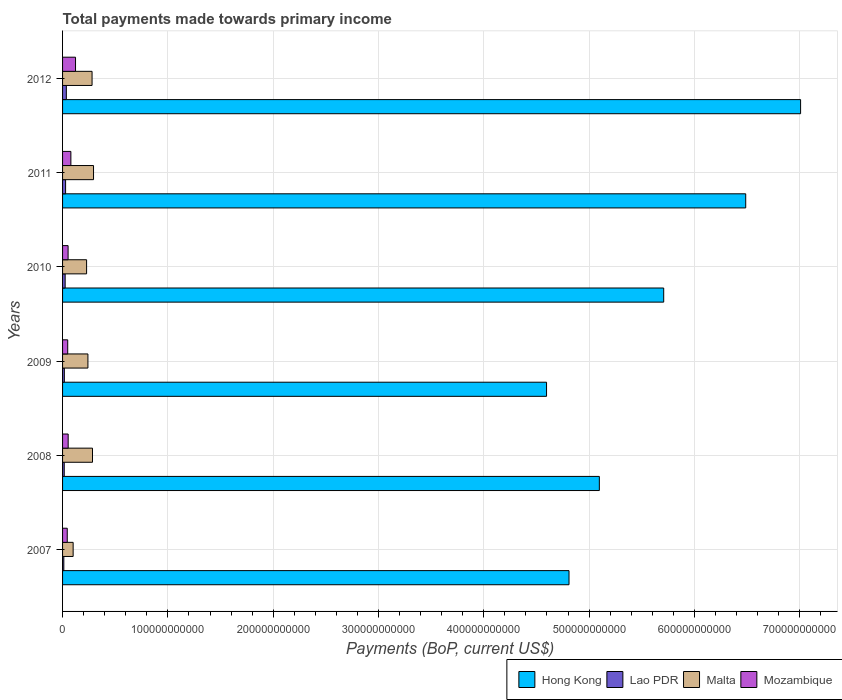How many different coloured bars are there?
Make the answer very short. 4. How many groups of bars are there?
Your response must be concise. 6. Are the number of bars per tick equal to the number of legend labels?
Make the answer very short. Yes. Are the number of bars on each tick of the Y-axis equal?
Keep it short and to the point. Yes. How many bars are there on the 3rd tick from the top?
Your answer should be very brief. 4. In how many cases, is the number of bars for a given year not equal to the number of legend labels?
Provide a succinct answer. 0. What is the total payments made towards primary income in Hong Kong in 2010?
Offer a very short reply. 5.71e+11. Across all years, what is the maximum total payments made towards primary income in Lao PDR?
Your answer should be compact. 3.58e+09. Across all years, what is the minimum total payments made towards primary income in Lao PDR?
Offer a terse response. 1.20e+09. What is the total total payments made towards primary income in Lao PDR in the graph?
Provide a succinct answer. 1.34e+1. What is the difference between the total payments made towards primary income in Lao PDR in 2007 and that in 2011?
Your answer should be compact. -1.68e+09. What is the difference between the total payments made towards primary income in Malta in 2011 and the total payments made towards primary income in Mozambique in 2008?
Your answer should be compact. 2.41e+1. What is the average total payments made towards primary income in Mozambique per year?
Offer a very short reply. 6.69e+09. In the year 2008, what is the difference between the total payments made towards primary income in Lao PDR and total payments made towards primary income in Mozambique?
Give a very brief answer. -3.74e+09. What is the ratio of the total payments made towards primary income in Lao PDR in 2010 to that in 2012?
Make the answer very short. 0.69. Is the total payments made towards primary income in Mozambique in 2010 less than that in 2011?
Keep it short and to the point. Yes. Is the difference between the total payments made towards primary income in Lao PDR in 2009 and 2012 greater than the difference between the total payments made towards primary income in Mozambique in 2009 and 2012?
Ensure brevity in your answer.  Yes. What is the difference between the highest and the second highest total payments made towards primary income in Lao PDR?
Make the answer very short. 7.01e+08. What is the difference between the highest and the lowest total payments made towards primary income in Mozambique?
Your answer should be compact. 7.85e+09. In how many years, is the total payments made towards primary income in Hong Kong greater than the average total payments made towards primary income in Hong Kong taken over all years?
Keep it short and to the point. 3. Is the sum of the total payments made towards primary income in Malta in 2008 and 2012 greater than the maximum total payments made towards primary income in Mozambique across all years?
Provide a succinct answer. Yes. What does the 3rd bar from the top in 2012 represents?
Provide a short and direct response. Lao PDR. What does the 4th bar from the bottom in 2009 represents?
Give a very brief answer. Mozambique. Are all the bars in the graph horizontal?
Your response must be concise. Yes. How many years are there in the graph?
Offer a very short reply. 6. What is the difference between two consecutive major ticks on the X-axis?
Offer a very short reply. 1.00e+11. Are the values on the major ticks of X-axis written in scientific E-notation?
Keep it short and to the point. No. Does the graph contain any zero values?
Keep it short and to the point. No. Does the graph contain grids?
Your answer should be very brief. Yes. Where does the legend appear in the graph?
Your answer should be very brief. Bottom right. What is the title of the graph?
Offer a terse response. Total payments made towards primary income. What is the label or title of the X-axis?
Keep it short and to the point. Payments (BoP, current US$). What is the Payments (BoP, current US$) of Hong Kong in 2007?
Make the answer very short. 4.81e+11. What is the Payments (BoP, current US$) in Lao PDR in 2007?
Your answer should be compact. 1.20e+09. What is the Payments (BoP, current US$) in Malta in 2007?
Make the answer very short. 1.00e+1. What is the Payments (BoP, current US$) of Mozambique in 2007?
Make the answer very short. 4.45e+09. What is the Payments (BoP, current US$) of Hong Kong in 2008?
Provide a short and direct response. 5.10e+11. What is the Payments (BoP, current US$) in Lao PDR in 2008?
Ensure brevity in your answer.  1.59e+09. What is the Payments (BoP, current US$) in Malta in 2008?
Make the answer very short. 2.84e+1. What is the Payments (BoP, current US$) of Mozambique in 2008?
Offer a very short reply. 5.33e+09. What is the Payments (BoP, current US$) of Hong Kong in 2009?
Make the answer very short. 4.60e+11. What is the Payments (BoP, current US$) of Lao PDR in 2009?
Ensure brevity in your answer.  1.69e+09. What is the Payments (BoP, current US$) of Malta in 2009?
Your answer should be very brief. 2.41e+1. What is the Payments (BoP, current US$) in Mozambique in 2009?
Your response must be concise. 4.89e+09. What is the Payments (BoP, current US$) of Hong Kong in 2010?
Keep it short and to the point. 5.71e+11. What is the Payments (BoP, current US$) in Lao PDR in 2010?
Your answer should be compact. 2.46e+09. What is the Payments (BoP, current US$) in Malta in 2010?
Keep it short and to the point. 2.28e+1. What is the Payments (BoP, current US$) in Mozambique in 2010?
Ensure brevity in your answer.  5.24e+09. What is the Payments (BoP, current US$) in Hong Kong in 2011?
Your answer should be compact. 6.49e+11. What is the Payments (BoP, current US$) in Lao PDR in 2011?
Keep it short and to the point. 2.88e+09. What is the Payments (BoP, current US$) in Malta in 2011?
Ensure brevity in your answer.  2.94e+1. What is the Payments (BoP, current US$) of Mozambique in 2011?
Ensure brevity in your answer.  7.89e+09. What is the Payments (BoP, current US$) in Hong Kong in 2012?
Make the answer very short. 7.01e+11. What is the Payments (BoP, current US$) of Lao PDR in 2012?
Your answer should be very brief. 3.58e+09. What is the Payments (BoP, current US$) in Malta in 2012?
Provide a succinct answer. 2.80e+1. What is the Payments (BoP, current US$) of Mozambique in 2012?
Give a very brief answer. 1.23e+1. Across all years, what is the maximum Payments (BoP, current US$) in Hong Kong?
Ensure brevity in your answer.  7.01e+11. Across all years, what is the maximum Payments (BoP, current US$) in Lao PDR?
Your answer should be compact. 3.58e+09. Across all years, what is the maximum Payments (BoP, current US$) of Malta?
Ensure brevity in your answer.  2.94e+1. Across all years, what is the maximum Payments (BoP, current US$) in Mozambique?
Keep it short and to the point. 1.23e+1. Across all years, what is the minimum Payments (BoP, current US$) in Hong Kong?
Make the answer very short. 4.60e+11. Across all years, what is the minimum Payments (BoP, current US$) of Lao PDR?
Give a very brief answer. 1.20e+09. Across all years, what is the minimum Payments (BoP, current US$) of Malta?
Provide a short and direct response. 1.00e+1. Across all years, what is the minimum Payments (BoP, current US$) of Mozambique?
Keep it short and to the point. 4.45e+09. What is the total Payments (BoP, current US$) of Hong Kong in the graph?
Your answer should be compact. 3.37e+12. What is the total Payments (BoP, current US$) in Lao PDR in the graph?
Your response must be concise. 1.34e+1. What is the total Payments (BoP, current US$) of Malta in the graph?
Provide a short and direct response. 1.43e+11. What is the total Payments (BoP, current US$) in Mozambique in the graph?
Offer a very short reply. 4.01e+1. What is the difference between the Payments (BoP, current US$) of Hong Kong in 2007 and that in 2008?
Offer a very short reply. -2.88e+1. What is the difference between the Payments (BoP, current US$) in Lao PDR in 2007 and that in 2008?
Your response must be concise. -3.86e+08. What is the difference between the Payments (BoP, current US$) of Malta in 2007 and that in 2008?
Ensure brevity in your answer.  -1.84e+1. What is the difference between the Payments (BoP, current US$) in Mozambique in 2007 and that in 2008?
Your answer should be very brief. -8.72e+08. What is the difference between the Payments (BoP, current US$) of Hong Kong in 2007 and that in 2009?
Your answer should be compact. 2.13e+1. What is the difference between the Payments (BoP, current US$) in Lao PDR in 2007 and that in 2009?
Keep it short and to the point. -4.83e+08. What is the difference between the Payments (BoP, current US$) of Malta in 2007 and that in 2009?
Provide a short and direct response. -1.40e+1. What is the difference between the Payments (BoP, current US$) in Mozambique in 2007 and that in 2009?
Ensure brevity in your answer.  -4.41e+08. What is the difference between the Payments (BoP, current US$) in Hong Kong in 2007 and that in 2010?
Provide a succinct answer. -8.99e+1. What is the difference between the Payments (BoP, current US$) of Lao PDR in 2007 and that in 2010?
Your response must be concise. -1.25e+09. What is the difference between the Payments (BoP, current US$) of Malta in 2007 and that in 2010?
Offer a very short reply. -1.28e+1. What is the difference between the Payments (BoP, current US$) of Mozambique in 2007 and that in 2010?
Offer a very short reply. -7.92e+08. What is the difference between the Payments (BoP, current US$) of Hong Kong in 2007 and that in 2011?
Your response must be concise. -1.68e+11. What is the difference between the Payments (BoP, current US$) of Lao PDR in 2007 and that in 2011?
Your answer should be compact. -1.68e+09. What is the difference between the Payments (BoP, current US$) in Malta in 2007 and that in 2011?
Your answer should be compact. -1.94e+1. What is the difference between the Payments (BoP, current US$) in Mozambique in 2007 and that in 2011?
Offer a terse response. -3.44e+09. What is the difference between the Payments (BoP, current US$) of Hong Kong in 2007 and that in 2012?
Offer a terse response. -2.20e+11. What is the difference between the Payments (BoP, current US$) in Lao PDR in 2007 and that in 2012?
Give a very brief answer. -2.38e+09. What is the difference between the Payments (BoP, current US$) in Malta in 2007 and that in 2012?
Ensure brevity in your answer.  -1.80e+1. What is the difference between the Payments (BoP, current US$) of Mozambique in 2007 and that in 2012?
Keep it short and to the point. -7.85e+09. What is the difference between the Payments (BoP, current US$) in Hong Kong in 2008 and that in 2009?
Give a very brief answer. 5.01e+1. What is the difference between the Payments (BoP, current US$) of Lao PDR in 2008 and that in 2009?
Give a very brief answer. -9.67e+07. What is the difference between the Payments (BoP, current US$) of Malta in 2008 and that in 2009?
Provide a short and direct response. 4.34e+09. What is the difference between the Payments (BoP, current US$) of Mozambique in 2008 and that in 2009?
Offer a terse response. 4.32e+08. What is the difference between the Payments (BoP, current US$) of Hong Kong in 2008 and that in 2010?
Offer a terse response. -6.11e+1. What is the difference between the Payments (BoP, current US$) in Lao PDR in 2008 and that in 2010?
Your answer should be compact. -8.68e+08. What is the difference between the Payments (BoP, current US$) in Malta in 2008 and that in 2010?
Your response must be concise. 5.61e+09. What is the difference between the Payments (BoP, current US$) of Mozambique in 2008 and that in 2010?
Keep it short and to the point. 8.03e+07. What is the difference between the Payments (BoP, current US$) of Hong Kong in 2008 and that in 2011?
Your response must be concise. -1.39e+11. What is the difference between the Payments (BoP, current US$) in Lao PDR in 2008 and that in 2011?
Your response must be concise. -1.29e+09. What is the difference between the Payments (BoP, current US$) of Malta in 2008 and that in 2011?
Ensure brevity in your answer.  -9.86e+08. What is the difference between the Payments (BoP, current US$) of Mozambique in 2008 and that in 2011?
Offer a terse response. -2.57e+09. What is the difference between the Payments (BoP, current US$) in Hong Kong in 2008 and that in 2012?
Offer a very short reply. -1.91e+11. What is the difference between the Payments (BoP, current US$) of Lao PDR in 2008 and that in 2012?
Offer a terse response. -1.99e+09. What is the difference between the Payments (BoP, current US$) of Malta in 2008 and that in 2012?
Your answer should be very brief. 4.04e+08. What is the difference between the Payments (BoP, current US$) of Mozambique in 2008 and that in 2012?
Keep it short and to the point. -6.98e+09. What is the difference between the Payments (BoP, current US$) in Hong Kong in 2009 and that in 2010?
Give a very brief answer. -1.11e+11. What is the difference between the Payments (BoP, current US$) in Lao PDR in 2009 and that in 2010?
Your answer should be very brief. -7.72e+08. What is the difference between the Payments (BoP, current US$) in Malta in 2009 and that in 2010?
Make the answer very short. 1.27e+09. What is the difference between the Payments (BoP, current US$) in Mozambique in 2009 and that in 2010?
Provide a succinct answer. -3.51e+08. What is the difference between the Payments (BoP, current US$) in Hong Kong in 2009 and that in 2011?
Keep it short and to the point. -1.89e+11. What is the difference between the Payments (BoP, current US$) in Lao PDR in 2009 and that in 2011?
Provide a succinct answer. -1.20e+09. What is the difference between the Payments (BoP, current US$) of Malta in 2009 and that in 2011?
Ensure brevity in your answer.  -5.32e+09. What is the difference between the Payments (BoP, current US$) in Mozambique in 2009 and that in 2011?
Offer a very short reply. -3.00e+09. What is the difference between the Payments (BoP, current US$) of Hong Kong in 2009 and that in 2012?
Make the answer very short. -2.41e+11. What is the difference between the Payments (BoP, current US$) in Lao PDR in 2009 and that in 2012?
Give a very brief answer. -1.90e+09. What is the difference between the Payments (BoP, current US$) of Malta in 2009 and that in 2012?
Keep it short and to the point. -3.93e+09. What is the difference between the Payments (BoP, current US$) of Mozambique in 2009 and that in 2012?
Keep it short and to the point. -7.41e+09. What is the difference between the Payments (BoP, current US$) in Hong Kong in 2010 and that in 2011?
Your response must be concise. -7.79e+1. What is the difference between the Payments (BoP, current US$) in Lao PDR in 2010 and that in 2011?
Keep it short and to the point. -4.24e+08. What is the difference between the Payments (BoP, current US$) of Malta in 2010 and that in 2011?
Provide a succinct answer. -6.59e+09. What is the difference between the Payments (BoP, current US$) in Mozambique in 2010 and that in 2011?
Offer a terse response. -2.65e+09. What is the difference between the Payments (BoP, current US$) of Hong Kong in 2010 and that in 2012?
Offer a very short reply. -1.30e+11. What is the difference between the Payments (BoP, current US$) in Lao PDR in 2010 and that in 2012?
Provide a succinct answer. -1.12e+09. What is the difference between the Payments (BoP, current US$) in Malta in 2010 and that in 2012?
Provide a succinct answer. -5.20e+09. What is the difference between the Payments (BoP, current US$) in Mozambique in 2010 and that in 2012?
Keep it short and to the point. -7.06e+09. What is the difference between the Payments (BoP, current US$) of Hong Kong in 2011 and that in 2012?
Make the answer very short. -5.21e+1. What is the difference between the Payments (BoP, current US$) in Lao PDR in 2011 and that in 2012?
Provide a short and direct response. -7.01e+08. What is the difference between the Payments (BoP, current US$) of Malta in 2011 and that in 2012?
Provide a short and direct response. 1.39e+09. What is the difference between the Payments (BoP, current US$) in Mozambique in 2011 and that in 2012?
Give a very brief answer. -4.41e+09. What is the difference between the Payments (BoP, current US$) of Hong Kong in 2007 and the Payments (BoP, current US$) of Lao PDR in 2008?
Offer a very short reply. 4.79e+11. What is the difference between the Payments (BoP, current US$) in Hong Kong in 2007 and the Payments (BoP, current US$) in Malta in 2008?
Your answer should be compact. 4.53e+11. What is the difference between the Payments (BoP, current US$) of Hong Kong in 2007 and the Payments (BoP, current US$) of Mozambique in 2008?
Offer a very short reply. 4.76e+11. What is the difference between the Payments (BoP, current US$) of Lao PDR in 2007 and the Payments (BoP, current US$) of Malta in 2008?
Provide a short and direct response. -2.72e+1. What is the difference between the Payments (BoP, current US$) in Lao PDR in 2007 and the Payments (BoP, current US$) in Mozambique in 2008?
Offer a very short reply. -4.12e+09. What is the difference between the Payments (BoP, current US$) in Malta in 2007 and the Payments (BoP, current US$) in Mozambique in 2008?
Your response must be concise. 4.72e+09. What is the difference between the Payments (BoP, current US$) in Hong Kong in 2007 and the Payments (BoP, current US$) in Lao PDR in 2009?
Your answer should be very brief. 4.79e+11. What is the difference between the Payments (BoP, current US$) in Hong Kong in 2007 and the Payments (BoP, current US$) in Malta in 2009?
Offer a terse response. 4.57e+11. What is the difference between the Payments (BoP, current US$) of Hong Kong in 2007 and the Payments (BoP, current US$) of Mozambique in 2009?
Keep it short and to the point. 4.76e+11. What is the difference between the Payments (BoP, current US$) of Lao PDR in 2007 and the Payments (BoP, current US$) of Malta in 2009?
Your answer should be very brief. -2.29e+1. What is the difference between the Payments (BoP, current US$) of Lao PDR in 2007 and the Payments (BoP, current US$) of Mozambique in 2009?
Make the answer very short. -3.69e+09. What is the difference between the Payments (BoP, current US$) of Malta in 2007 and the Payments (BoP, current US$) of Mozambique in 2009?
Provide a short and direct response. 5.15e+09. What is the difference between the Payments (BoP, current US$) of Hong Kong in 2007 and the Payments (BoP, current US$) of Lao PDR in 2010?
Your answer should be compact. 4.78e+11. What is the difference between the Payments (BoP, current US$) of Hong Kong in 2007 and the Payments (BoP, current US$) of Malta in 2010?
Provide a short and direct response. 4.58e+11. What is the difference between the Payments (BoP, current US$) in Hong Kong in 2007 and the Payments (BoP, current US$) in Mozambique in 2010?
Your answer should be compact. 4.76e+11. What is the difference between the Payments (BoP, current US$) in Lao PDR in 2007 and the Payments (BoP, current US$) in Malta in 2010?
Offer a terse response. -2.16e+1. What is the difference between the Payments (BoP, current US$) of Lao PDR in 2007 and the Payments (BoP, current US$) of Mozambique in 2010?
Make the answer very short. -4.04e+09. What is the difference between the Payments (BoP, current US$) in Malta in 2007 and the Payments (BoP, current US$) in Mozambique in 2010?
Make the answer very short. 4.80e+09. What is the difference between the Payments (BoP, current US$) of Hong Kong in 2007 and the Payments (BoP, current US$) of Lao PDR in 2011?
Your answer should be very brief. 4.78e+11. What is the difference between the Payments (BoP, current US$) in Hong Kong in 2007 and the Payments (BoP, current US$) in Malta in 2011?
Make the answer very short. 4.52e+11. What is the difference between the Payments (BoP, current US$) of Hong Kong in 2007 and the Payments (BoP, current US$) of Mozambique in 2011?
Give a very brief answer. 4.73e+11. What is the difference between the Payments (BoP, current US$) of Lao PDR in 2007 and the Payments (BoP, current US$) of Malta in 2011?
Ensure brevity in your answer.  -2.82e+1. What is the difference between the Payments (BoP, current US$) in Lao PDR in 2007 and the Payments (BoP, current US$) in Mozambique in 2011?
Make the answer very short. -6.69e+09. What is the difference between the Payments (BoP, current US$) in Malta in 2007 and the Payments (BoP, current US$) in Mozambique in 2011?
Your response must be concise. 2.15e+09. What is the difference between the Payments (BoP, current US$) of Hong Kong in 2007 and the Payments (BoP, current US$) of Lao PDR in 2012?
Make the answer very short. 4.77e+11. What is the difference between the Payments (BoP, current US$) in Hong Kong in 2007 and the Payments (BoP, current US$) in Malta in 2012?
Offer a terse response. 4.53e+11. What is the difference between the Payments (BoP, current US$) in Hong Kong in 2007 and the Payments (BoP, current US$) in Mozambique in 2012?
Offer a terse response. 4.69e+11. What is the difference between the Payments (BoP, current US$) of Lao PDR in 2007 and the Payments (BoP, current US$) of Malta in 2012?
Provide a short and direct response. -2.68e+1. What is the difference between the Payments (BoP, current US$) in Lao PDR in 2007 and the Payments (BoP, current US$) in Mozambique in 2012?
Ensure brevity in your answer.  -1.11e+1. What is the difference between the Payments (BoP, current US$) of Malta in 2007 and the Payments (BoP, current US$) of Mozambique in 2012?
Offer a very short reply. -2.26e+09. What is the difference between the Payments (BoP, current US$) of Hong Kong in 2008 and the Payments (BoP, current US$) of Lao PDR in 2009?
Give a very brief answer. 5.08e+11. What is the difference between the Payments (BoP, current US$) in Hong Kong in 2008 and the Payments (BoP, current US$) in Malta in 2009?
Offer a very short reply. 4.86e+11. What is the difference between the Payments (BoP, current US$) in Hong Kong in 2008 and the Payments (BoP, current US$) in Mozambique in 2009?
Ensure brevity in your answer.  5.05e+11. What is the difference between the Payments (BoP, current US$) in Lao PDR in 2008 and the Payments (BoP, current US$) in Malta in 2009?
Your answer should be very brief. -2.25e+1. What is the difference between the Payments (BoP, current US$) in Lao PDR in 2008 and the Payments (BoP, current US$) in Mozambique in 2009?
Your answer should be compact. -3.30e+09. What is the difference between the Payments (BoP, current US$) of Malta in 2008 and the Payments (BoP, current US$) of Mozambique in 2009?
Your response must be concise. 2.35e+1. What is the difference between the Payments (BoP, current US$) of Hong Kong in 2008 and the Payments (BoP, current US$) of Lao PDR in 2010?
Your response must be concise. 5.07e+11. What is the difference between the Payments (BoP, current US$) in Hong Kong in 2008 and the Payments (BoP, current US$) in Malta in 2010?
Your answer should be compact. 4.87e+11. What is the difference between the Payments (BoP, current US$) in Hong Kong in 2008 and the Payments (BoP, current US$) in Mozambique in 2010?
Your response must be concise. 5.04e+11. What is the difference between the Payments (BoP, current US$) in Lao PDR in 2008 and the Payments (BoP, current US$) in Malta in 2010?
Make the answer very short. -2.12e+1. What is the difference between the Payments (BoP, current US$) of Lao PDR in 2008 and the Payments (BoP, current US$) of Mozambique in 2010?
Keep it short and to the point. -3.66e+09. What is the difference between the Payments (BoP, current US$) of Malta in 2008 and the Payments (BoP, current US$) of Mozambique in 2010?
Your answer should be very brief. 2.32e+1. What is the difference between the Payments (BoP, current US$) of Hong Kong in 2008 and the Payments (BoP, current US$) of Lao PDR in 2011?
Offer a terse response. 5.07e+11. What is the difference between the Payments (BoP, current US$) of Hong Kong in 2008 and the Payments (BoP, current US$) of Malta in 2011?
Your answer should be compact. 4.80e+11. What is the difference between the Payments (BoP, current US$) of Hong Kong in 2008 and the Payments (BoP, current US$) of Mozambique in 2011?
Offer a terse response. 5.02e+11. What is the difference between the Payments (BoP, current US$) of Lao PDR in 2008 and the Payments (BoP, current US$) of Malta in 2011?
Your response must be concise. -2.78e+1. What is the difference between the Payments (BoP, current US$) in Lao PDR in 2008 and the Payments (BoP, current US$) in Mozambique in 2011?
Make the answer very short. -6.30e+09. What is the difference between the Payments (BoP, current US$) of Malta in 2008 and the Payments (BoP, current US$) of Mozambique in 2011?
Ensure brevity in your answer.  2.05e+1. What is the difference between the Payments (BoP, current US$) in Hong Kong in 2008 and the Payments (BoP, current US$) in Lao PDR in 2012?
Offer a terse response. 5.06e+11. What is the difference between the Payments (BoP, current US$) of Hong Kong in 2008 and the Payments (BoP, current US$) of Malta in 2012?
Provide a succinct answer. 4.82e+11. What is the difference between the Payments (BoP, current US$) of Hong Kong in 2008 and the Payments (BoP, current US$) of Mozambique in 2012?
Your answer should be compact. 4.97e+11. What is the difference between the Payments (BoP, current US$) in Lao PDR in 2008 and the Payments (BoP, current US$) in Malta in 2012?
Your response must be concise. -2.64e+1. What is the difference between the Payments (BoP, current US$) in Lao PDR in 2008 and the Payments (BoP, current US$) in Mozambique in 2012?
Offer a terse response. -1.07e+1. What is the difference between the Payments (BoP, current US$) in Malta in 2008 and the Payments (BoP, current US$) in Mozambique in 2012?
Make the answer very short. 1.61e+1. What is the difference between the Payments (BoP, current US$) of Hong Kong in 2009 and the Payments (BoP, current US$) of Lao PDR in 2010?
Offer a terse response. 4.57e+11. What is the difference between the Payments (BoP, current US$) in Hong Kong in 2009 and the Payments (BoP, current US$) in Malta in 2010?
Ensure brevity in your answer.  4.37e+11. What is the difference between the Payments (BoP, current US$) in Hong Kong in 2009 and the Payments (BoP, current US$) in Mozambique in 2010?
Your response must be concise. 4.54e+11. What is the difference between the Payments (BoP, current US$) of Lao PDR in 2009 and the Payments (BoP, current US$) of Malta in 2010?
Your answer should be compact. -2.11e+1. What is the difference between the Payments (BoP, current US$) of Lao PDR in 2009 and the Payments (BoP, current US$) of Mozambique in 2010?
Provide a succinct answer. -3.56e+09. What is the difference between the Payments (BoP, current US$) of Malta in 2009 and the Payments (BoP, current US$) of Mozambique in 2010?
Your answer should be very brief. 1.88e+1. What is the difference between the Payments (BoP, current US$) in Hong Kong in 2009 and the Payments (BoP, current US$) in Lao PDR in 2011?
Provide a succinct answer. 4.57e+11. What is the difference between the Payments (BoP, current US$) in Hong Kong in 2009 and the Payments (BoP, current US$) in Malta in 2011?
Offer a terse response. 4.30e+11. What is the difference between the Payments (BoP, current US$) of Hong Kong in 2009 and the Payments (BoP, current US$) of Mozambique in 2011?
Your answer should be very brief. 4.52e+11. What is the difference between the Payments (BoP, current US$) in Lao PDR in 2009 and the Payments (BoP, current US$) in Malta in 2011?
Offer a very short reply. -2.77e+1. What is the difference between the Payments (BoP, current US$) in Lao PDR in 2009 and the Payments (BoP, current US$) in Mozambique in 2011?
Provide a short and direct response. -6.21e+09. What is the difference between the Payments (BoP, current US$) in Malta in 2009 and the Payments (BoP, current US$) in Mozambique in 2011?
Make the answer very short. 1.62e+1. What is the difference between the Payments (BoP, current US$) in Hong Kong in 2009 and the Payments (BoP, current US$) in Lao PDR in 2012?
Provide a succinct answer. 4.56e+11. What is the difference between the Payments (BoP, current US$) in Hong Kong in 2009 and the Payments (BoP, current US$) in Malta in 2012?
Keep it short and to the point. 4.32e+11. What is the difference between the Payments (BoP, current US$) in Hong Kong in 2009 and the Payments (BoP, current US$) in Mozambique in 2012?
Offer a very short reply. 4.47e+11. What is the difference between the Payments (BoP, current US$) of Lao PDR in 2009 and the Payments (BoP, current US$) of Malta in 2012?
Keep it short and to the point. -2.63e+1. What is the difference between the Payments (BoP, current US$) of Lao PDR in 2009 and the Payments (BoP, current US$) of Mozambique in 2012?
Give a very brief answer. -1.06e+1. What is the difference between the Payments (BoP, current US$) of Malta in 2009 and the Payments (BoP, current US$) of Mozambique in 2012?
Offer a terse response. 1.18e+1. What is the difference between the Payments (BoP, current US$) in Hong Kong in 2010 and the Payments (BoP, current US$) in Lao PDR in 2011?
Provide a short and direct response. 5.68e+11. What is the difference between the Payments (BoP, current US$) of Hong Kong in 2010 and the Payments (BoP, current US$) of Malta in 2011?
Give a very brief answer. 5.41e+11. What is the difference between the Payments (BoP, current US$) of Hong Kong in 2010 and the Payments (BoP, current US$) of Mozambique in 2011?
Your answer should be very brief. 5.63e+11. What is the difference between the Payments (BoP, current US$) in Lao PDR in 2010 and the Payments (BoP, current US$) in Malta in 2011?
Provide a succinct answer. -2.69e+1. What is the difference between the Payments (BoP, current US$) in Lao PDR in 2010 and the Payments (BoP, current US$) in Mozambique in 2011?
Provide a short and direct response. -5.43e+09. What is the difference between the Payments (BoP, current US$) in Malta in 2010 and the Payments (BoP, current US$) in Mozambique in 2011?
Your answer should be very brief. 1.49e+1. What is the difference between the Payments (BoP, current US$) in Hong Kong in 2010 and the Payments (BoP, current US$) in Lao PDR in 2012?
Provide a succinct answer. 5.67e+11. What is the difference between the Payments (BoP, current US$) of Hong Kong in 2010 and the Payments (BoP, current US$) of Malta in 2012?
Provide a succinct answer. 5.43e+11. What is the difference between the Payments (BoP, current US$) in Hong Kong in 2010 and the Payments (BoP, current US$) in Mozambique in 2012?
Your response must be concise. 5.59e+11. What is the difference between the Payments (BoP, current US$) in Lao PDR in 2010 and the Payments (BoP, current US$) in Malta in 2012?
Make the answer very short. -2.56e+1. What is the difference between the Payments (BoP, current US$) of Lao PDR in 2010 and the Payments (BoP, current US$) of Mozambique in 2012?
Make the answer very short. -9.85e+09. What is the difference between the Payments (BoP, current US$) in Malta in 2010 and the Payments (BoP, current US$) in Mozambique in 2012?
Offer a very short reply. 1.05e+1. What is the difference between the Payments (BoP, current US$) of Hong Kong in 2011 and the Payments (BoP, current US$) of Lao PDR in 2012?
Offer a very short reply. 6.45e+11. What is the difference between the Payments (BoP, current US$) of Hong Kong in 2011 and the Payments (BoP, current US$) of Malta in 2012?
Your answer should be very brief. 6.21e+11. What is the difference between the Payments (BoP, current US$) in Hong Kong in 2011 and the Payments (BoP, current US$) in Mozambique in 2012?
Keep it short and to the point. 6.36e+11. What is the difference between the Payments (BoP, current US$) of Lao PDR in 2011 and the Payments (BoP, current US$) of Malta in 2012?
Your answer should be compact. -2.51e+1. What is the difference between the Payments (BoP, current US$) in Lao PDR in 2011 and the Payments (BoP, current US$) in Mozambique in 2012?
Ensure brevity in your answer.  -9.42e+09. What is the difference between the Payments (BoP, current US$) in Malta in 2011 and the Payments (BoP, current US$) in Mozambique in 2012?
Keep it short and to the point. 1.71e+1. What is the average Payments (BoP, current US$) in Hong Kong per year?
Offer a very short reply. 5.62e+11. What is the average Payments (BoP, current US$) of Lao PDR per year?
Ensure brevity in your answer.  2.23e+09. What is the average Payments (BoP, current US$) in Malta per year?
Ensure brevity in your answer.  2.38e+1. What is the average Payments (BoP, current US$) in Mozambique per year?
Provide a succinct answer. 6.69e+09. In the year 2007, what is the difference between the Payments (BoP, current US$) in Hong Kong and Payments (BoP, current US$) in Lao PDR?
Your answer should be very brief. 4.80e+11. In the year 2007, what is the difference between the Payments (BoP, current US$) of Hong Kong and Payments (BoP, current US$) of Malta?
Provide a succinct answer. 4.71e+11. In the year 2007, what is the difference between the Payments (BoP, current US$) of Hong Kong and Payments (BoP, current US$) of Mozambique?
Make the answer very short. 4.76e+11. In the year 2007, what is the difference between the Payments (BoP, current US$) of Lao PDR and Payments (BoP, current US$) of Malta?
Keep it short and to the point. -8.84e+09. In the year 2007, what is the difference between the Payments (BoP, current US$) in Lao PDR and Payments (BoP, current US$) in Mozambique?
Give a very brief answer. -3.25e+09. In the year 2007, what is the difference between the Payments (BoP, current US$) in Malta and Payments (BoP, current US$) in Mozambique?
Provide a succinct answer. 5.59e+09. In the year 2008, what is the difference between the Payments (BoP, current US$) in Hong Kong and Payments (BoP, current US$) in Lao PDR?
Ensure brevity in your answer.  5.08e+11. In the year 2008, what is the difference between the Payments (BoP, current US$) in Hong Kong and Payments (BoP, current US$) in Malta?
Provide a short and direct response. 4.81e+11. In the year 2008, what is the difference between the Payments (BoP, current US$) of Hong Kong and Payments (BoP, current US$) of Mozambique?
Offer a terse response. 5.04e+11. In the year 2008, what is the difference between the Payments (BoP, current US$) in Lao PDR and Payments (BoP, current US$) in Malta?
Provide a succinct answer. -2.68e+1. In the year 2008, what is the difference between the Payments (BoP, current US$) in Lao PDR and Payments (BoP, current US$) in Mozambique?
Make the answer very short. -3.74e+09. In the year 2008, what is the difference between the Payments (BoP, current US$) in Malta and Payments (BoP, current US$) in Mozambique?
Your answer should be compact. 2.31e+1. In the year 2009, what is the difference between the Payments (BoP, current US$) in Hong Kong and Payments (BoP, current US$) in Lao PDR?
Offer a terse response. 4.58e+11. In the year 2009, what is the difference between the Payments (BoP, current US$) of Hong Kong and Payments (BoP, current US$) of Malta?
Offer a very short reply. 4.36e+11. In the year 2009, what is the difference between the Payments (BoP, current US$) in Hong Kong and Payments (BoP, current US$) in Mozambique?
Your answer should be compact. 4.55e+11. In the year 2009, what is the difference between the Payments (BoP, current US$) of Lao PDR and Payments (BoP, current US$) of Malta?
Make the answer very short. -2.24e+1. In the year 2009, what is the difference between the Payments (BoP, current US$) of Lao PDR and Payments (BoP, current US$) of Mozambique?
Offer a terse response. -3.21e+09. In the year 2009, what is the difference between the Payments (BoP, current US$) in Malta and Payments (BoP, current US$) in Mozambique?
Offer a terse response. 1.92e+1. In the year 2010, what is the difference between the Payments (BoP, current US$) in Hong Kong and Payments (BoP, current US$) in Lao PDR?
Keep it short and to the point. 5.68e+11. In the year 2010, what is the difference between the Payments (BoP, current US$) in Hong Kong and Payments (BoP, current US$) in Malta?
Provide a short and direct response. 5.48e+11. In the year 2010, what is the difference between the Payments (BoP, current US$) in Hong Kong and Payments (BoP, current US$) in Mozambique?
Offer a very short reply. 5.66e+11. In the year 2010, what is the difference between the Payments (BoP, current US$) in Lao PDR and Payments (BoP, current US$) in Malta?
Give a very brief answer. -2.04e+1. In the year 2010, what is the difference between the Payments (BoP, current US$) of Lao PDR and Payments (BoP, current US$) of Mozambique?
Your response must be concise. -2.79e+09. In the year 2010, what is the difference between the Payments (BoP, current US$) of Malta and Payments (BoP, current US$) of Mozambique?
Make the answer very short. 1.76e+1. In the year 2011, what is the difference between the Payments (BoP, current US$) of Hong Kong and Payments (BoP, current US$) of Lao PDR?
Provide a succinct answer. 6.46e+11. In the year 2011, what is the difference between the Payments (BoP, current US$) of Hong Kong and Payments (BoP, current US$) of Malta?
Provide a short and direct response. 6.19e+11. In the year 2011, what is the difference between the Payments (BoP, current US$) in Hong Kong and Payments (BoP, current US$) in Mozambique?
Your answer should be very brief. 6.41e+11. In the year 2011, what is the difference between the Payments (BoP, current US$) of Lao PDR and Payments (BoP, current US$) of Malta?
Keep it short and to the point. -2.65e+1. In the year 2011, what is the difference between the Payments (BoP, current US$) in Lao PDR and Payments (BoP, current US$) in Mozambique?
Make the answer very short. -5.01e+09. In the year 2011, what is the difference between the Payments (BoP, current US$) of Malta and Payments (BoP, current US$) of Mozambique?
Give a very brief answer. 2.15e+1. In the year 2012, what is the difference between the Payments (BoP, current US$) in Hong Kong and Payments (BoP, current US$) in Lao PDR?
Make the answer very short. 6.97e+11. In the year 2012, what is the difference between the Payments (BoP, current US$) of Hong Kong and Payments (BoP, current US$) of Malta?
Make the answer very short. 6.73e+11. In the year 2012, what is the difference between the Payments (BoP, current US$) in Hong Kong and Payments (BoP, current US$) in Mozambique?
Make the answer very short. 6.89e+11. In the year 2012, what is the difference between the Payments (BoP, current US$) in Lao PDR and Payments (BoP, current US$) in Malta?
Your response must be concise. -2.44e+1. In the year 2012, what is the difference between the Payments (BoP, current US$) in Lao PDR and Payments (BoP, current US$) in Mozambique?
Ensure brevity in your answer.  -8.72e+09. In the year 2012, what is the difference between the Payments (BoP, current US$) of Malta and Payments (BoP, current US$) of Mozambique?
Your answer should be very brief. 1.57e+1. What is the ratio of the Payments (BoP, current US$) of Hong Kong in 2007 to that in 2008?
Give a very brief answer. 0.94. What is the ratio of the Payments (BoP, current US$) in Lao PDR in 2007 to that in 2008?
Give a very brief answer. 0.76. What is the ratio of the Payments (BoP, current US$) of Malta in 2007 to that in 2008?
Give a very brief answer. 0.35. What is the ratio of the Payments (BoP, current US$) of Mozambique in 2007 to that in 2008?
Ensure brevity in your answer.  0.84. What is the ratio of the Payments (BoP, current US$) in Hong Kong in 2007 to that in 2009?
Your answer should be very brief. 1.05. What is the ratio of the Payments (BoP, current US$) of Lao PDR in 2007 to that in 2009?
Make the answer very short. 0.71. What is the ratio of the Payments (BoP, current US$) of Malta in 2007 to that in 2009?
Provide a short and direct response. 0.42. What is the ratio of the Payments (BoP, current US$) of Mozambique in 2007 to that in 2009?
Your answer should be very brief. 0.91. What is the ratio of the Payments (BoP, current US$) in Hong Kong in 2007 to that in 2010?
Make the answer very short. 0.84. What is the ratio of the Payments (BoP, current US$) of Lao PDR in 2007 to that in 2010?
Provide a succinct answer. 0.49. What is the ratio of the Payments (BoP, current US$) of Malta in 2007 to that in 2010?
Keep it short and to the point. 0.44. What is the ratio of the Payments (BoP, current US$) of Mozambique in 2007 to that in 2010?
Offer a very short reply. 0.85. What is the ratio of the Payments (BoP, current US$) of Hong Kong in 2007 to that in 2011?
Ensure brevity in your answer.  0.74. What is the ratio of the Payments (BoP, current US$) in Lao PDR in 2007 to that in 2011?
Provide a short and direct response. 0.42. What is the ratio of the Payments (BoP, current US$) of Malta in 2007 to that in 2011?
Your answer should be very brief. 0.34. What is the ratio of the Payments (BoP, current US$) of Mozambique in 2007 to that in 2011?
Your answer should be very brief. 0.56. What is the ratio of the Payments (BoP, current US$) of Hong Kong in 2007 to that in 2012?
Give a very brief answer. 0.69. What is the ratio of the Payments (BoP, current US$) in Lao PDR in 2007 to that in 2012?
Ensure brevity in your answer.  0.34. What is the ratio of the Payments (BoP, current US$) of Malta in 2007 to that in 2012?
Provide a succinct answer. 0.36. What is the ratio of the Payments (BoP, current US$) in Mozambique in 2007 to that in 2012?
Your answer should be compact. 0.36. What is the ratio of the Payments (BoP, current US$) in Hong Kong in 2008 to that in 2009?
Offer a very short reply. 1.11. What is the ratio of the Payments (BoP, current US$) of Lao PDR in 2008 to that in 2009?
Provide a short and direct response. 0.94. What is the ratio of the Payments (BoP, current US$) of Malta in 2008 to that in 2009?
Provide a succinct answer. 1.18. What is the ratio of the Payments (BoP, current US$) of Mozambique in 2008 to that in 2009?
Your response must be concise. 1.09. What is the ratio of the Payments (BoP, current US$) of Hong Kong in 2008 to that in 2010?
Provide a succinct answer. 0.89. What is the ratio of the Payments (BoP, current US$) in Lao PDR in 2008 to that in 2010?
Offer a very short reply. 0.65. What is the ratio of the Payments (BoP, current US$) of Malta in 2008 to that in 2010?
Provide a succinct answer. 1.25. What is the ratio of the Payments (BoP, current US$) of Mozambique in 2008 to that in 2010?
Ensure brevity in your answer.  1.02. What is the ratio of the Payments (BoP, current US$) in Hong Kong in 2008 to that in 2011?
Ensure brevity in your answer.  0.79. What is the ratio of the Payments (BoP, current US$) of Lao PDR in 2008 to that in 2011?
Offer a very short reply. 0.55. What is the ratio of the Payments (BoP, current US$) in Malta in 2008 to that in 2011?
Offer a terse response. 0.97. What is the ratio of the Payments (BoP, current US$) in Mozambique in 2008 to that in 2011?
Provide a short and direct response. 0.67. What is the ratio of the Payments (BoP, current US$) in Hong Kong in 2008 to that in 2012?
Your answer should be very brief. 0.73. What is the ratio of the Payments (BoP, current US$) of Lao PDR in 2008 to that in 2012?
Your answer should be compact. 0.44. What is the ratio of the Payments (BoP, current US$) of Malta in 2008 to that in 2012?
Ensure brevity in your answer.  1.01. What is the ratio of the Payments (BoP, current US$) in Mozambique in 2008 to that in 2012?
Your answer should be very brief. 0.43. What is the ratio of the Payments (BoP, current US$) of Hong Kong in 2009 to that in 2010?
Your answer should be compact. 0.81. What is the ratio of the Payments (BoP, current US$) of Lao PDR in 2009 to that in 2010?
Make the answer very short. 0.69. What is the ratio of the Payments (BoP, current US$) in Malta in 2009 to that in 2010?
Provide a succinct answer. 1.06. What is the ratio of the Payments (BoP, current US$) in Mozambique in 2009 to that in 2010?
Provide a succinct answer. 0.93. What is the ratio of the Payments (BoP, current US$) in Hong Kong in 2009 to that in 2011?
Offer a very short reply. 0.71. What is the ratio of the Payments (BoP, current US$) of Lao PDR in 2009 to that in 2011?
Ensure brevity in your answer.  0.58. What is the ratio of the Payments (BoP, current US$) in Malta in 2009 to that in 2011?
Provide a short and direct response. 0.82. What is the ratio of the Payments (BoP, current US$) in Mozambique in 2009 to that in 2011?
Your answer should be very brief. 0.62. What is the ratio of the Payments (BoP, current US$) of Hong Kong in 2009 to that in 2012?
Provide a short and direct response. 0.66. What is the ratio of the Payments (BoP, current US$) in Lao PDR in 2009 to that in 2012?
Keep it short and to the point. 0.47. What is the ratio of the Payments (BoP, current US$) in Malta in 2009 to that in 2012?
Offer a terse response. 0.86. What is the ratio of the Payments (BoP, current US$) of Mozambique in 2009 to that in 2012?
Make the answer very short. 0.4. What is the ratio of the Payments (BoP, current US$) of Hong Kong in 2010 to that in 2011?
Your answer should be compact. 0.88. What is the ratio of the Payments (BoP, current US$) of Lao PDR in 2010 to that in 2011?
Keep it short and to the point. 0.85. What is the ratio of the Payments (BoP, current US$) in Malta in 2010 to that in 2011?
Provide a short and direct response. 0.78. What is the ratio of the Payments (BoP, current US$) of Mozambique in 2010 to that in 2011?
Offer a terse response. 0.66. What is the ratio of the Payments (BoP, current US$) of Hong Kong in 2010 to that in 2012?
Offer a terse response. 0.81. What is the ratio of the Payments (BoP, current US$) of Lao PDR in 2010 to that in 2012?
Offer a terse response. 0.69. What is the ratio of the Payments (BoP, current US$) in Malta in 2010 to that in 2012?
Ensure brevity in your answer.  0.81. What is the ratio of the Payments (BoP, current US$) of Mozambique in 2010 to that in 2012?
Offer a terse response. 0.43. What is the ratio of the Payments (BoP, current US$) of Hong Kong in 2011 to that in 2012?
Provide a short and direct response. 0.93. What is the ratio of the Payments (BoP, current US$) in Lao PDR in 2011 to that in 2012?
Your answer should be compact. 0.8. What is the ratio of the Payments (BoP, current US$) in Malta in 2011 to that in 2012?
Offer a terse response. 1.05. What is the ratio of the Payments (BoP, current US$) in Mozambique in 2011 to that in 2012?
Keep it short and to the point. 0.64. What is the difference between the highest and the second highest Payments (BoP, current US$) in Hong Kong?
Offer a terse response. 5.21e+1. What is the difference between the highest and the second highest Payments (BoP, current US$) in Lao PDR?
Give a very brief answer. 7.01e+08. What is the difference between the highest and the second highest Payments (BoP, current US$) of Malta?
Make the answer very short. 9.86e+08. What is the difference between the highest and the second highest Payments (BoP, current US$) in Mozambique?
Provide a succinct answer. 4.41e+09. What is the difference between the highest and the lowest Payments (BoP, current US$) of Hong Kong?
Make the answer very short. 2.41e+11. What is the difference between the highest and the lowest Payments (BoP, current US$) in Lao PDR?
Your response must be concise. 2.38e+09. What is the difference between the highest and the lowest Payments (BoP, current US$) of Malta?
Give a very brief answer. 1.94e+1. What is the difference between the highest and the lowest Payments (BoP, current US$) in Mozambique?
Make the answer very short. 7.85e+09. 